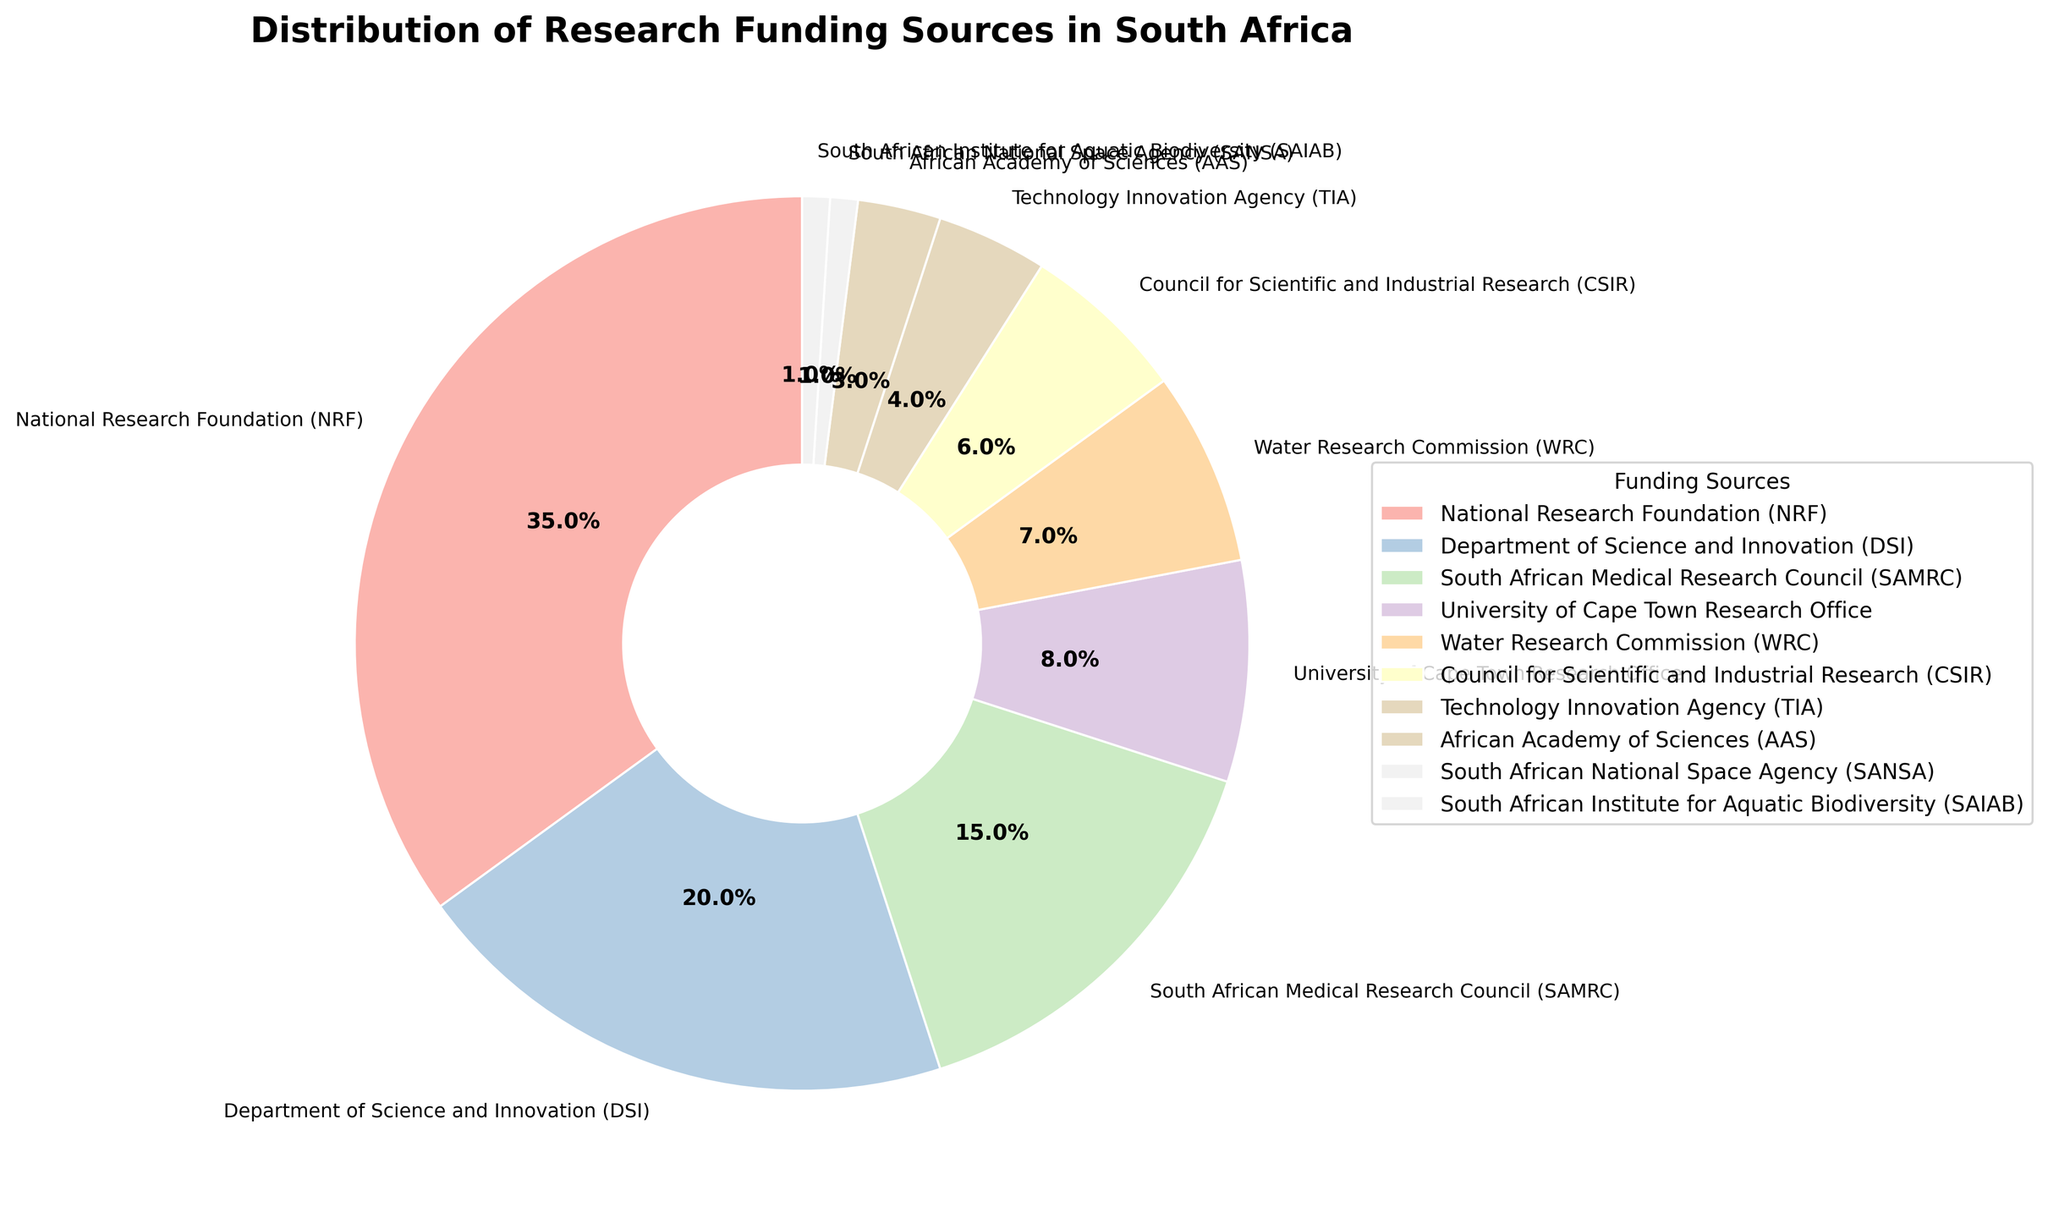Which funding source contributes the largest percentage to research funding in South Africa? The National Research Foundation (NRF) has the largest wedge in the pie chart, indicating the highest percentage.
Answer: National Research Foundation (NRF) What is the combined percentage of research funding provided by DSI and SAMRC? The DSI contributes 20% and SAMRC contributes 15%. Adding these together, 20% + 15% = 35%.
Answer: 35% Which funding sources have the same contribution to research funding? The South African National Space Agency (SANSA) and the South African Institute for Aquatic Biodiversity (SAIAB) both contribute 1%.
Answer: SANSA and SAIAB How does the contribution of the University of Cape Town Research Office compare to that of the Water Research Commission? The University of Cape Town Research Office contributes 8%, while the Water Research Commission contributes 7%. The former is 1% more than the latter.
Answer: The University of Cape Town Research Office contributes 1% more What is the total percentage of research funding contributed by organizations other than NRF, DSI, and SAMRC? The percentages for the other organizations are: 8% (UCT Research Office), 7% (WRC), 6% (CSIR), 4% (TIA), 3% (AAS), 1% (SANSA), and 1% (SAIAB). Adding these: 8 + 7 + 6 + 4 + 3 + 1 + 1 = 30%.
Answer: 30% Which funding source has the smallest contribution and how much is it? Both the South African National Space Agency (SANSA) and the South African Institute for Aquatic Biodiversity (SAIAB) have the smallest contributions, both at 1%.
Answer: SANSA and SAIAB, 1% What percentage of the pie chart is made up of contributions less than 10%? The contributions below 10% are from UCT Research Office (8%), WRC (7%), CSIR (6%), TIA (4%), AAS (3%), SANSA (1%), and SAIAB (1%). Adding these, 8 + 7 + 6 + 4 + 3 + 1 + 1 = 30%.
Answer: 30% If the contributions from TIA and AAS were to merge into one entity, what would be their combined percentage and how would this rank among the other sources? TIA contributes 4% and AAS contributes 3%. Their combined percentage would be 4% + 3% = 7%, ranking equal to the Water Research Commission's contribution.
Answer: 7%, tied with WRC 